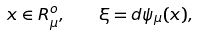<formula> <loc_0><loc_0><loc_500><loc_500>x \in R ^ { o } _ { \mu } , \quad \xi = d \psi _ { \mu } ( x ) ,</formula> 